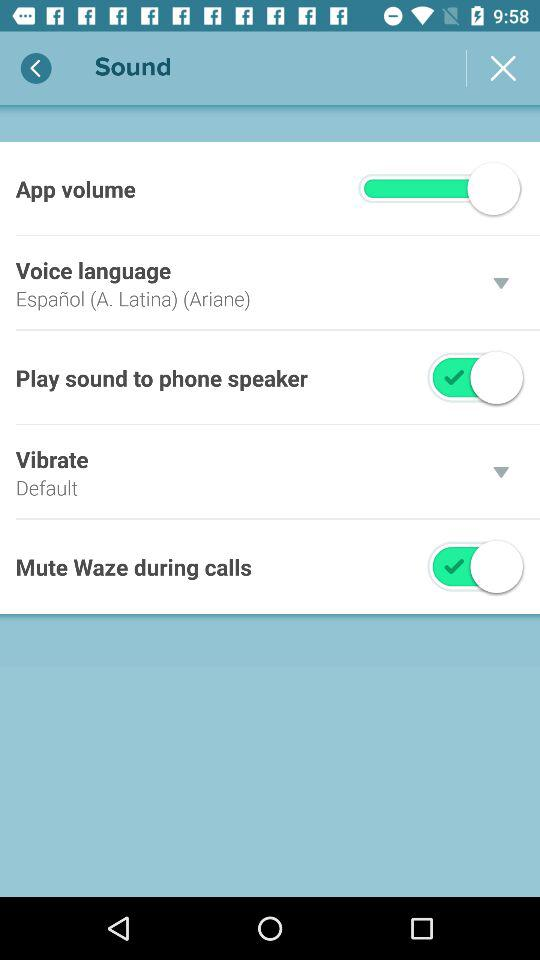Which options are "on"? The options that are "on" are "Play sound to phone speaker" and "Mute Waze during calls". 